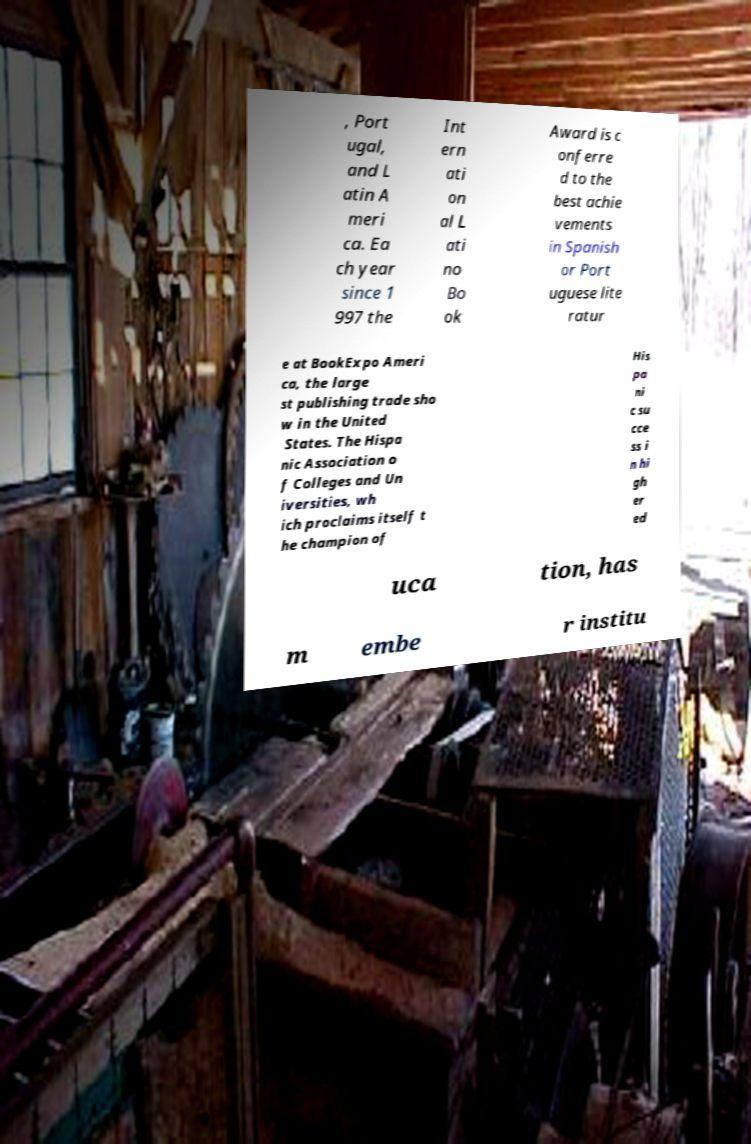Could you assist in decoding the text presented in this image and type it out clearly? , Port ugal, and L atin A meri ca. Ea ch year since 1 997 the Int ern ati on al L ati no Bo ok Award is c onferre d to the best achie vements in Spanish or Port uguese lite ratur e at BookExpo Ameri ca, the large st publishing trade sho w in the United States. The Hispa nic Association o f Colleges and Un iversities, wh ich proclaims itself t he champion of His pa ni c su cce ss i n hi gh er ed uca tion, has m embe r institu 